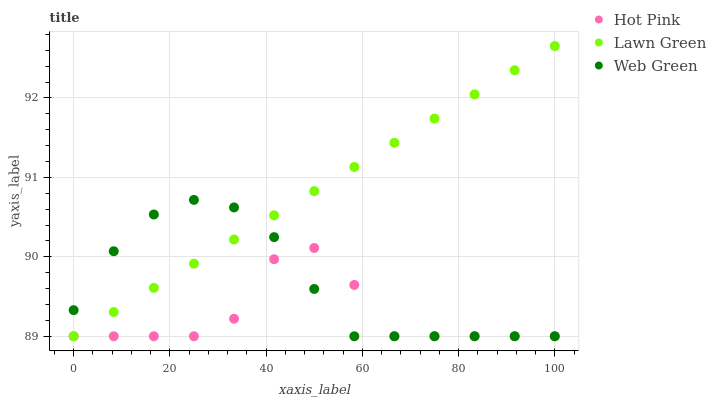Does Hot Pink have the minimum area under the curve?
Answer yes or no. Yes. Does Lawn Green have the maximum area under the curve?
Answer yes or no. Yes. Does Web Green have the minimum area under the curve?
Answer yes or no. No. Does Web Green have the maximum area under the curve?
Answer yes or no. No. Is Lawn Green the smoothest?
Answer yes or no. Yes. Is Hot Pink the roughest?
Answer yes or no. Yes. Is Web Green the smoothest?
Answer yes or no. No. Is Web Green the roughest?
Answer yes or no. No. Does Lawn Green have the lowest value?
Answer yes or no. Yes. Does Lawn Green have the highest value?
Answer yes or no. Yes. Does Web Green have the highest value?
Answer yes or no. No. Does Web Green intersect Lawn Green?
Answer yes or no. Yes. Is Web Green less than Lawn Green?
Answer yes or no. No. Is Web Green greater than Lawn Green?
Answer yes or no. No. 